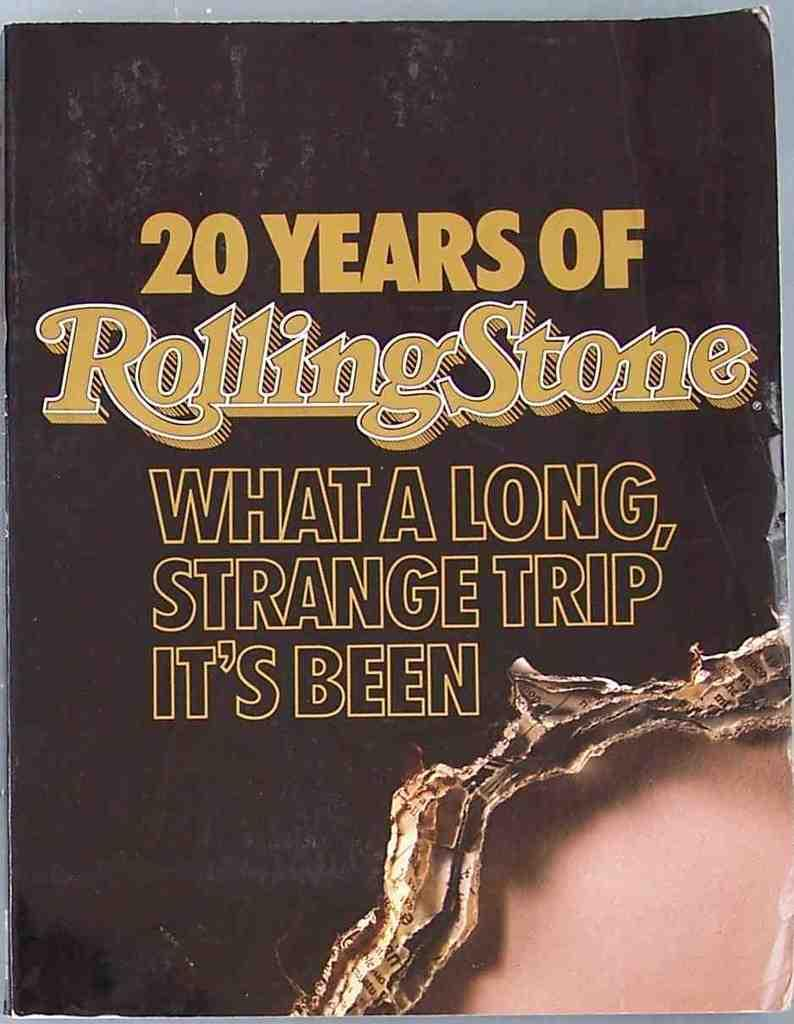<image>
Offer a succinct explanation of the picture presented. A cover of the magazine Rolling Stones which states  "What A Long Strange Trip It's Been". 